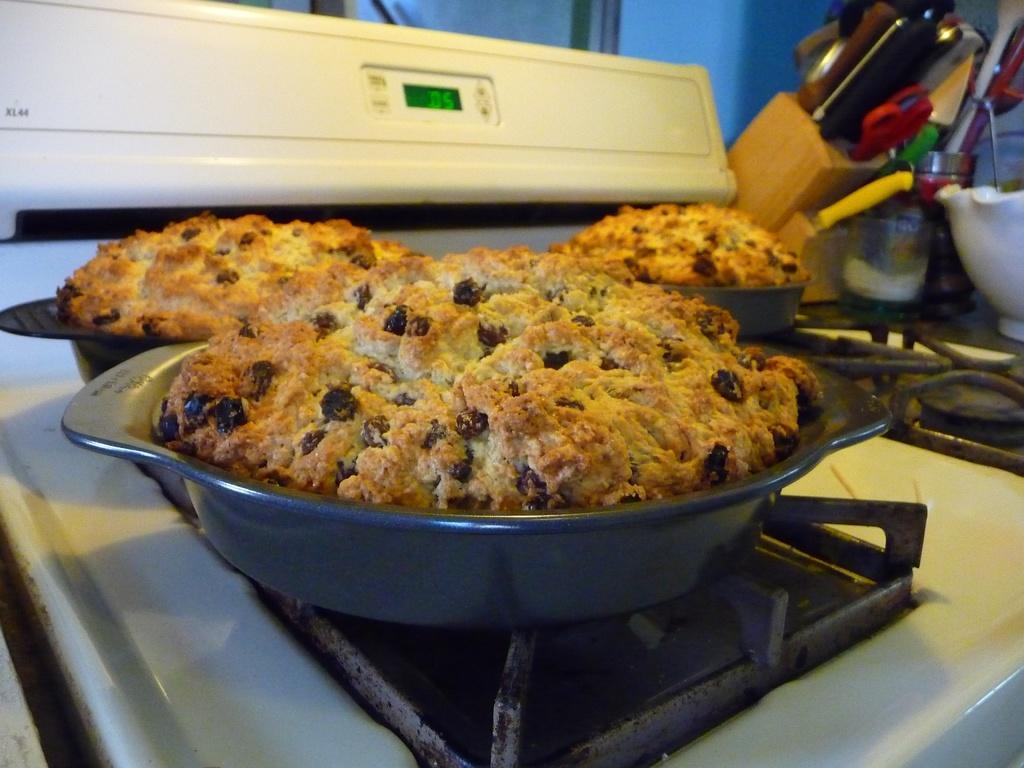In one or two sentences, can you explain what this image depicts? In this image there are cookies on trays, the trays are on top of the stove, beside the stove there are knives, scissors and some other objects. 